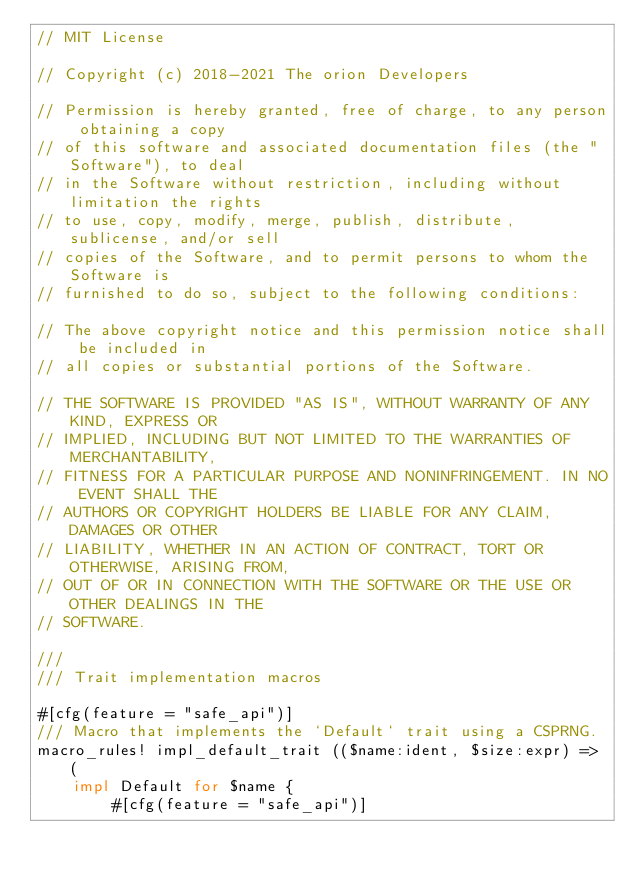<code> <loc_0><loc_0><loc_500><loc_500><_Rust_>// MIT License

// Copyright (c) 2018-2021 The orion Developers

// Permission is hereby granted, free of charge, to any person obtaining a copy
// of this software and associated documentation files (the "Software"), to deal
// in the Software without restriction, including without limitation the rights
// to use, copy, modify, merge, publish, distribute, sublicense, and/or sell
// copies of the Software, and to permit persons to whom the Software is
// furnished to do so, subject to the following conditions:

// The above copyright notice and this permission notice shall be included in
// all copies or substantial portions of the Software.

// THE SOFTWARE IS PROVIDED "AS IS", WITHOUT WARRANTY OF ANY KIND, EXPRESS OR
// IMPLIED, INCLUDING BUT NOT LIMITED TO THE WARRANTIES OF MERCHANTABILITY,
// FITNESS FOR A PARTICULAR PURPOSE AND NONINFRINGEMENT. IN NO EVENT SHALL THE
// AUTHORS OR COPYRIGHT HOLDERS BE LIABLE FOR ANY CLAIM, DAMAGES OR OTHER
// LIABILITY, WHETHER IN AN ACTION OF CONTRACT, TORT OR OTHERWISE, ARISING FROM,
// OUT OF OR IN CONNECTION WITH THE SOFTWARE OR THE USE OR OTHER DEALINGS IN THE
// SOFTWARE.

///
/// Trait implementation macros

#[cfg(feature = "safe_api")]
/// Macro that implements the `Default` trait using a CSPRNG.
macro_rules! impl_default_trait (($name:ident, $size:expr) => (
    impl Default for $name {
        #[cfg(feature = "safe_api")]</code> 